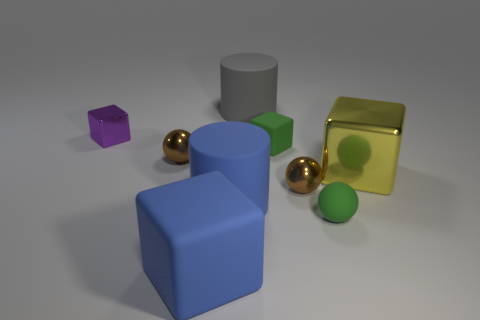Which objects in the image seem to be the same height? In this image, the purple cube and the smaller green cube seem to share a similar height, standing at a comparable level above the surface. 